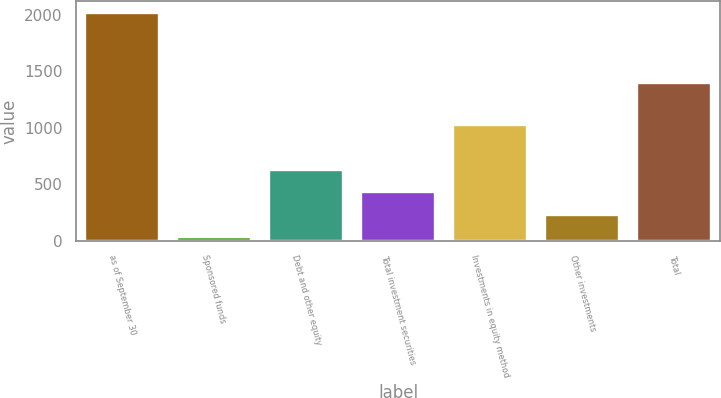<chart> <loc_0><loc_0><loc_500><loc_500><bar_chart><fcel>as of September 30<fcel>Sponsored funds<fcel>Debt and other equity<fcel>Total investment securities<fcel>Investments in equity method<fcel>Other investments<fcel>Total<nl><fcel>2017<fcel>31.1<fcel>626.87<fcel>428.28<fcel>1024.05<fcel>229.69<fcel>1393.6<nl></chart> 